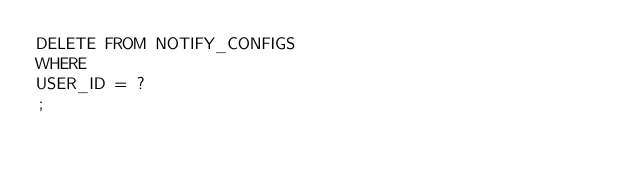Convert code to text. <code><loc_0><loc_0><loc_500><loc_500><_SQL_>DELETE FROM NOTIFY_CONFIGS
WHERE 
USER_ID = ?
;
</code> 